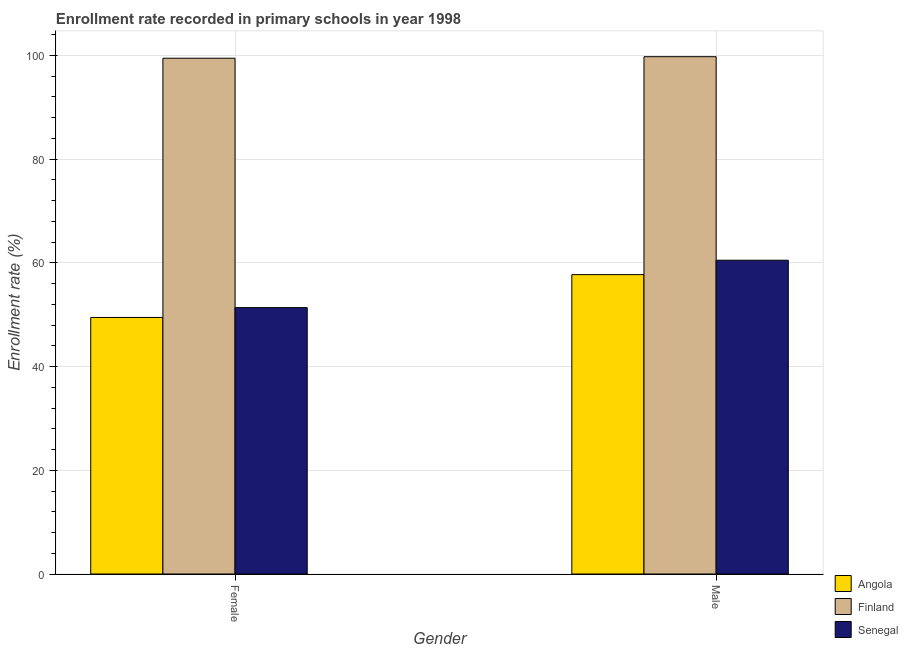How many different coloured bars are there?
Your answer should be compact. 3. How many groups of bars are there?
Provide a short and direct response. 2. How many bars are there on the 1st tick from the right?
Provide a succinct answer. 3. What is the enrollment rate of female students in Angola?
Offer a terse response. 49.47. Across all countries, what is the maximum enrollment rate of male students?
Keep it short and to the point. 99.76. Across all countries, what is the minimum enrollment rate of male students?
Your response must be concise. 57.73. In which country was the enrollment rate of female students minimum?
Ensure brevity in your answer.  Angola. What is the total enrollment rate of female students in the graph?
Offer a terse response. 200.3. What is the difference between the enrollment rate of female students in Angola and that in Finland?
Provide a succinct answer. -49.99. What is the difference between the enrollment rate of male students in Senegal and the enrollment rate of female students in Angola?
Give a very brief answer. 11.04. What is the average enrollment rate of male students per country?
Keep it short and to the point. 72.67. What is the difference between the enrollment rate of female students and enrollment rate of male students in Angola?
Provide a short and direct response. -8.26. In how many countries, is the enrollment rate of male students greater than 60 %?
Your answer should be compact. 2. What is the ratio of the enrollment rate of female students in Finland to that in Senegal?
Provide a succinct answer. 1.94. In how many countries, is the enrollment rate of male students greater than the average enrollment rate of male students taken over all countries?
Make the answer very short. 1. What does the 3rd bar from the left in Male represents?
Provide a succinct answer. Senegal. What does the 3rd bar from the right in Female represents?
Your response must be concise. Angola. Does the graph contain grids?
Make the answer very short. Yes. Where does the legend appear in the graph?
Offer a terse response. Bottom right. What is the title of the graph?
Provide a succinct answer. Enrollment rate recorded in primary schools in year 1998. What is the label or title of the Y-axis?
Your answer should be very brief. Enrollment rate (%). What is the Enrollment rate (%) in Angola in Female?
Ensure brevity in your answer.  49.47. What is the Enrollment rate (%) in Finland in Female?
Offer a very short reply. 99.46. What is the Enrollment rate (%) of Senegal in Female?
Ensure brevity in your answer.  51.37. What is the Enrollment rate (%) of Angola in Male?
Your answer should be very brief. 57.73. What is the Enrollment rate (%) of Finland in Male?
Offer a very short reply. 99.76. What is the Enrollment rate (%) of Senegal in Male?
Ensure brevity in your answer.  60.51. Across all Gender, what is the maximum Enrollment rate (%) of Angola?
Provide a short and direct response. 57.73. Across all Gender, what is the maximum Enrollment rate (%) of Finland?
Give a very brief answer. 99.76. Across all Gender, what is the maximum Enrollment rate (%) in Senegal?
Your response must be concise. 60.51. Across all Gender, what is the minimum Enrollment rate (%) in Angola?
Your answer should be compact. 49.47. Across all Gender, what is the minimum Enrollment rate (%) in Finland?
Keep it short and to the point. 99.46. Across all Gender, what is the minimum Enrollment rate (%) of Senegal?
Give a very brief answer. 51.37. What is the total Enrollment rate (%) of Angola in the graph?
Offer a very short reply. 107.2. What is the total Enrollment rate (%) of Finland in the graph?
Make the answer very short. 199.22. What is the total Enrollment rate (%) of Senegal in the graph?
Make the answer very short. 111.88. What is the difference between the Enrollment rate (%) in Angola in Female and that in Male?
Ensure brevity in your answer.  -8.26. What is the difference between the Enrollment rate (%) of Finland in Female and that in Male?
Your answer should be compact. -0.3. What is the difference between the Enrollment rate (%) in Senegal in Female and that in Male?
Offer a very short reply. -9.14. What is the difference between the Enrollment rate (%) of Angola in Female and the Enrollment rate (%) of Finland in Male?
Provide a short and direct response. -50.29. What is the difference between the Enrollment rate (%) in Angola in Female and the Enrollment rate (%) in Senegal in Male?
Offer a terse response. -11.04. What is the difference between the Enrollment rate (%) of Finland in Female and the Enrollment rate (%) of Senegal in Male?
Offer a very short reply. 38.95. What is the average Enrollment rate (%) of Angola per Gender?
Ensure brevity in your answer.  53.6. What is the average Enrollment rate (%) of Finland per Gender?
Your answer should be compact. 99.61. What is the average Enrollment rate (%) of Senegal per Gender?
Keep it short and to the point. 55.94. What is the difference between the Enrollment rate (%) in Angola and Enrollment rate (%) in Finland in Female?
Your answer should be very brief. -49.99. What is the difference between the Enrollment rate (%) of Angola and Enrollment rate (%) of Senegal in Female?
Your answer should be very brief. -1.9. What is the difference between the Enrollment rate (%) of Finland and Enrollment rate (%) of Senegal in Female?
Provide a short and direct response. 48.09. What is the difference between the Enrollment rate (%) in Angola and Enrollment rate (%) in Finland in Male?
Your answer should be compact. -42.03. What is the difference between the Enrollment rate (%) in Angola and Enrollment rate (%) in Senegal in Male?
Your answer should be compact. -2.78. What is the difference between the Enrollment rate (%) in Finland and Enrollment rate (%) in Senegal in Male?
Provide a succinct answer. 39.25. What is the ratio of the Enrollment rate (%) in Angola in Female to that in Male?
Make the answer very short. 0.86. What is the ratio of the Enrollment rate (%) of Finland in Female to that in Male?
Your answer should be compact. 1. What is the ratio of the Enrollment rate (%) of Senegal in Female to that in Male?
Your answer should be very brief. 0.85. What is the difference between the highest and the second highest Enrollment rate (%) of Angola?
Make the answer very short. 8.26. What is the difference between the highest and the second highest Enrollment rate (%) in Finland?
Keep it short and to the point. 0.3. What is the difference between the highest and the second highest Enrollment rate (%) in Senegal?
Offer a terse response. 9.14. What is the difference between the highest and the lowest Enrollment rate (%) in Angola?
Keep it short and to the point. 8.26. What is the difference between the highest and the lowest Enrollment rate (%) of Finland?
Keep it short and to the point. 0.3. What is the difference between the highest and the lowest Enrollment rate (%) of Senegal?
Ensure brevity in your answer.  9.14. 